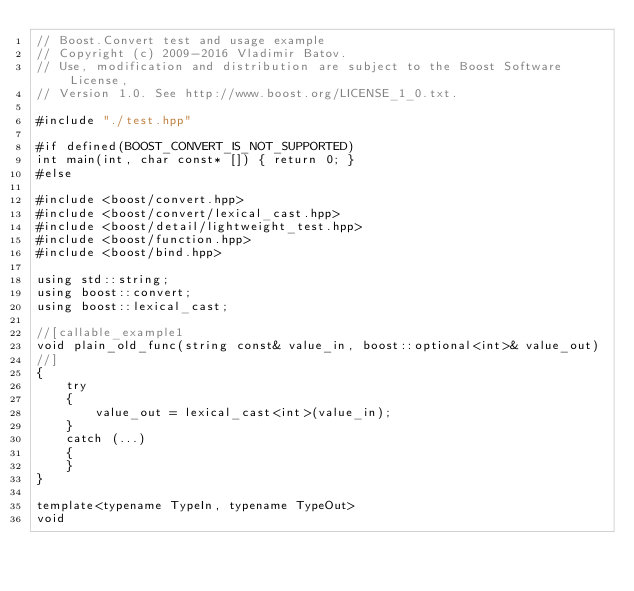Convert code to text. <code><loc_0><loc_0><loc_500><loc_500><_C++_>// Boost.Convert test and usage example
// Copyright (c) 2009-2016 Vladimir Batov.
// Use, modification and distribution are subject to the Boost Software License,
// Version 1.0. See http://www.boost.org/LICENSE_1_0.txt.

#include "./test.hpp"

#if defined(BOOST_CONVERT_IS_NOT_SUPPORTED)
int main(int, char const* []) { return 0; }
#else

#include <boost/convert.hpp>
#include <boost/convert/lexical_cast.hpp>
#include <boost/detail/lightweight_test.hpp>
#include <boost/function.hpp>
#include <boost/bind.hpp>

using std::string;
using boost::convert;
using boost::lexical_cast;

//[callable_example1
void plain_old_func(string const& value_in, boost::optional<int>& value_out)
//]
{
    try
    {
        value_out = lexical_cast<int>(value_in);
    }
    catch (...)
    {
    }
}

template<typename TypeIn, typename TypeOut>
void</code> 